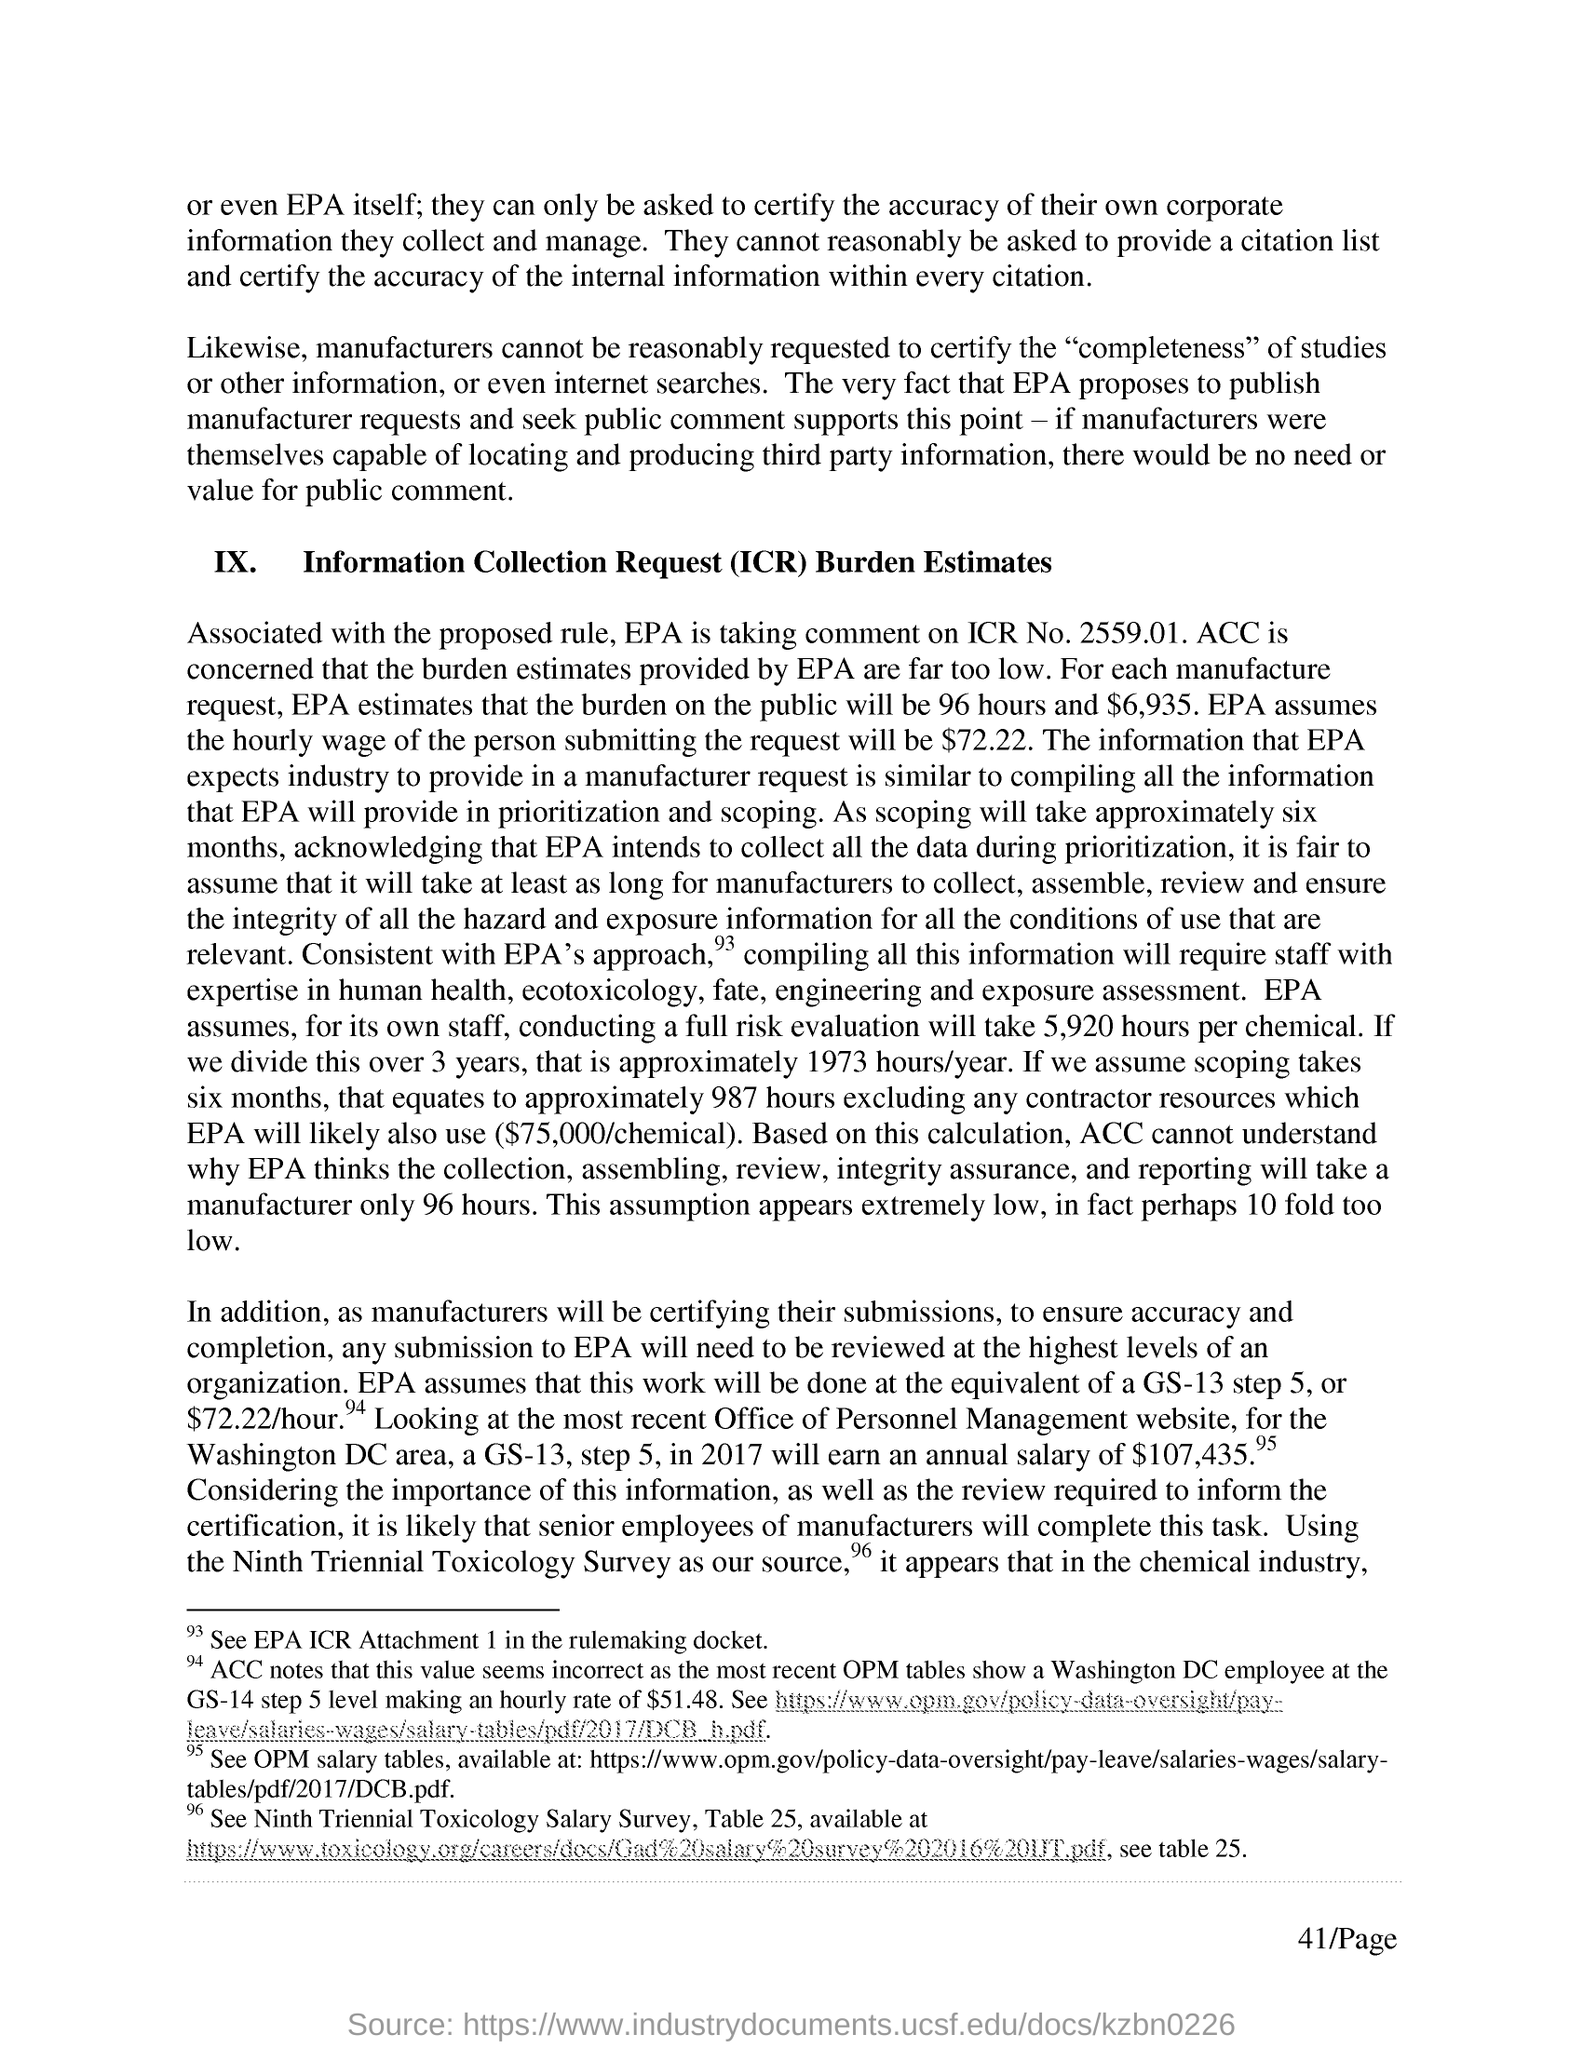Identify some key points in this picture. The Environmental Protection Agency is accepting comments on ICR No. 2559.01, which is a request for information related to a specific topic. ICR stands for Information Collection Request. For each manufacturer request, the estimated burden on the public is approximately 96 hours. 